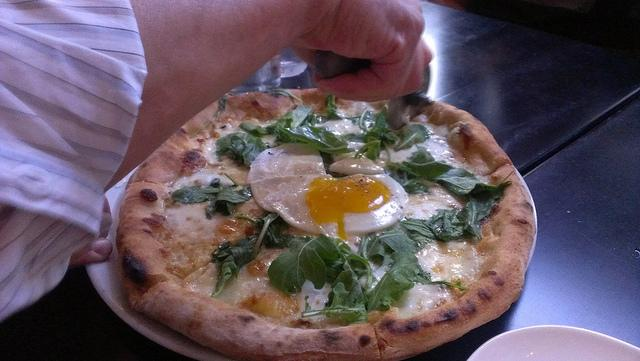What kind of bird created something that sits on this pizza? Please explain your reasoning. chicken. There is an egg in the middle of the pizza, and birds are known to lay eggs. 